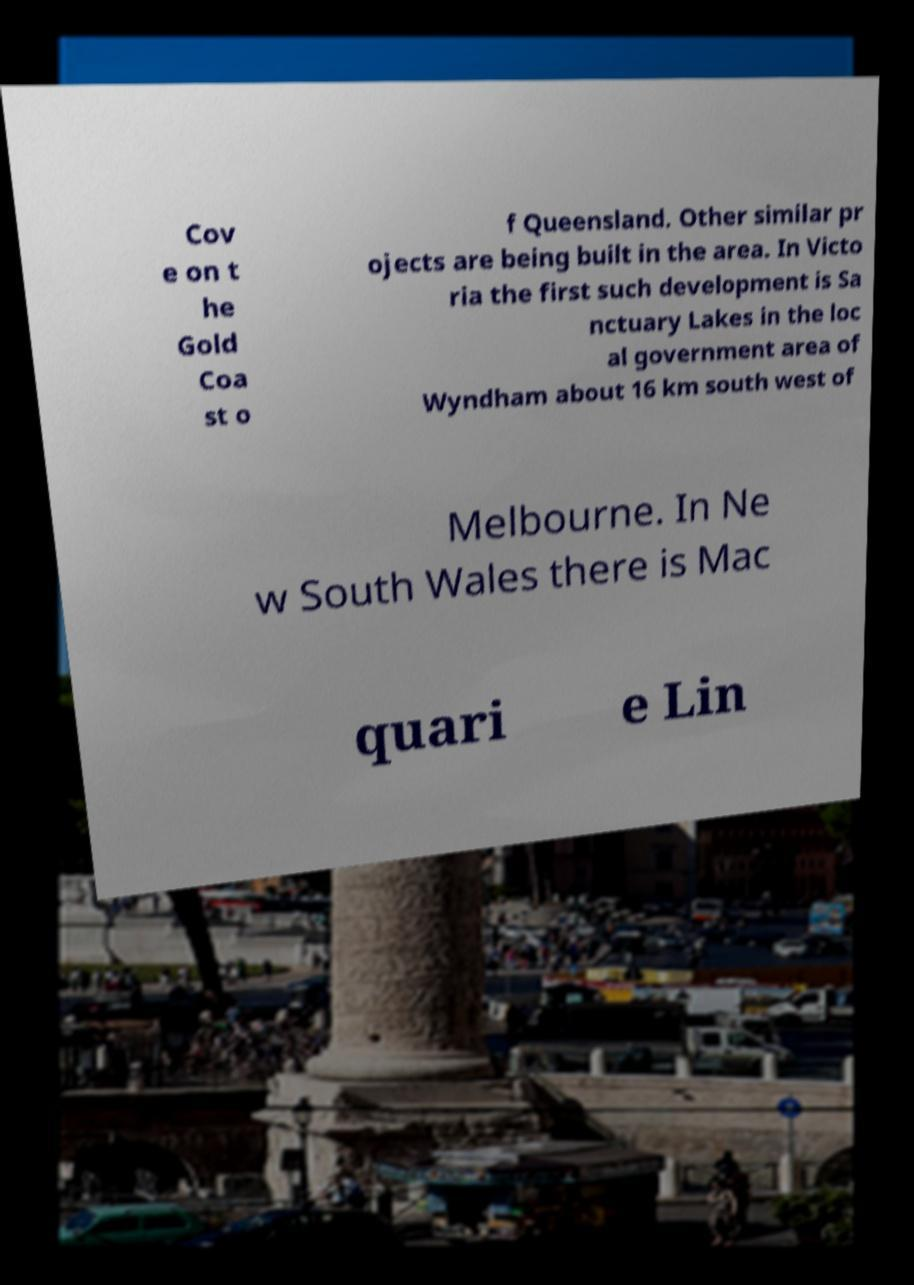There's text embedded in this image that I need extracted. Can you transcribe it verbatim? Cov e on t he Gold Coa st o f Queensland. Other similar pr ojects are being built in the area. In Victo ria the first such development is Sa nctuary Lakes in the loc al government area of Wyndham about 16 km south west of Melbourne. In Ne w South Wales there is Mac quari e Lin 